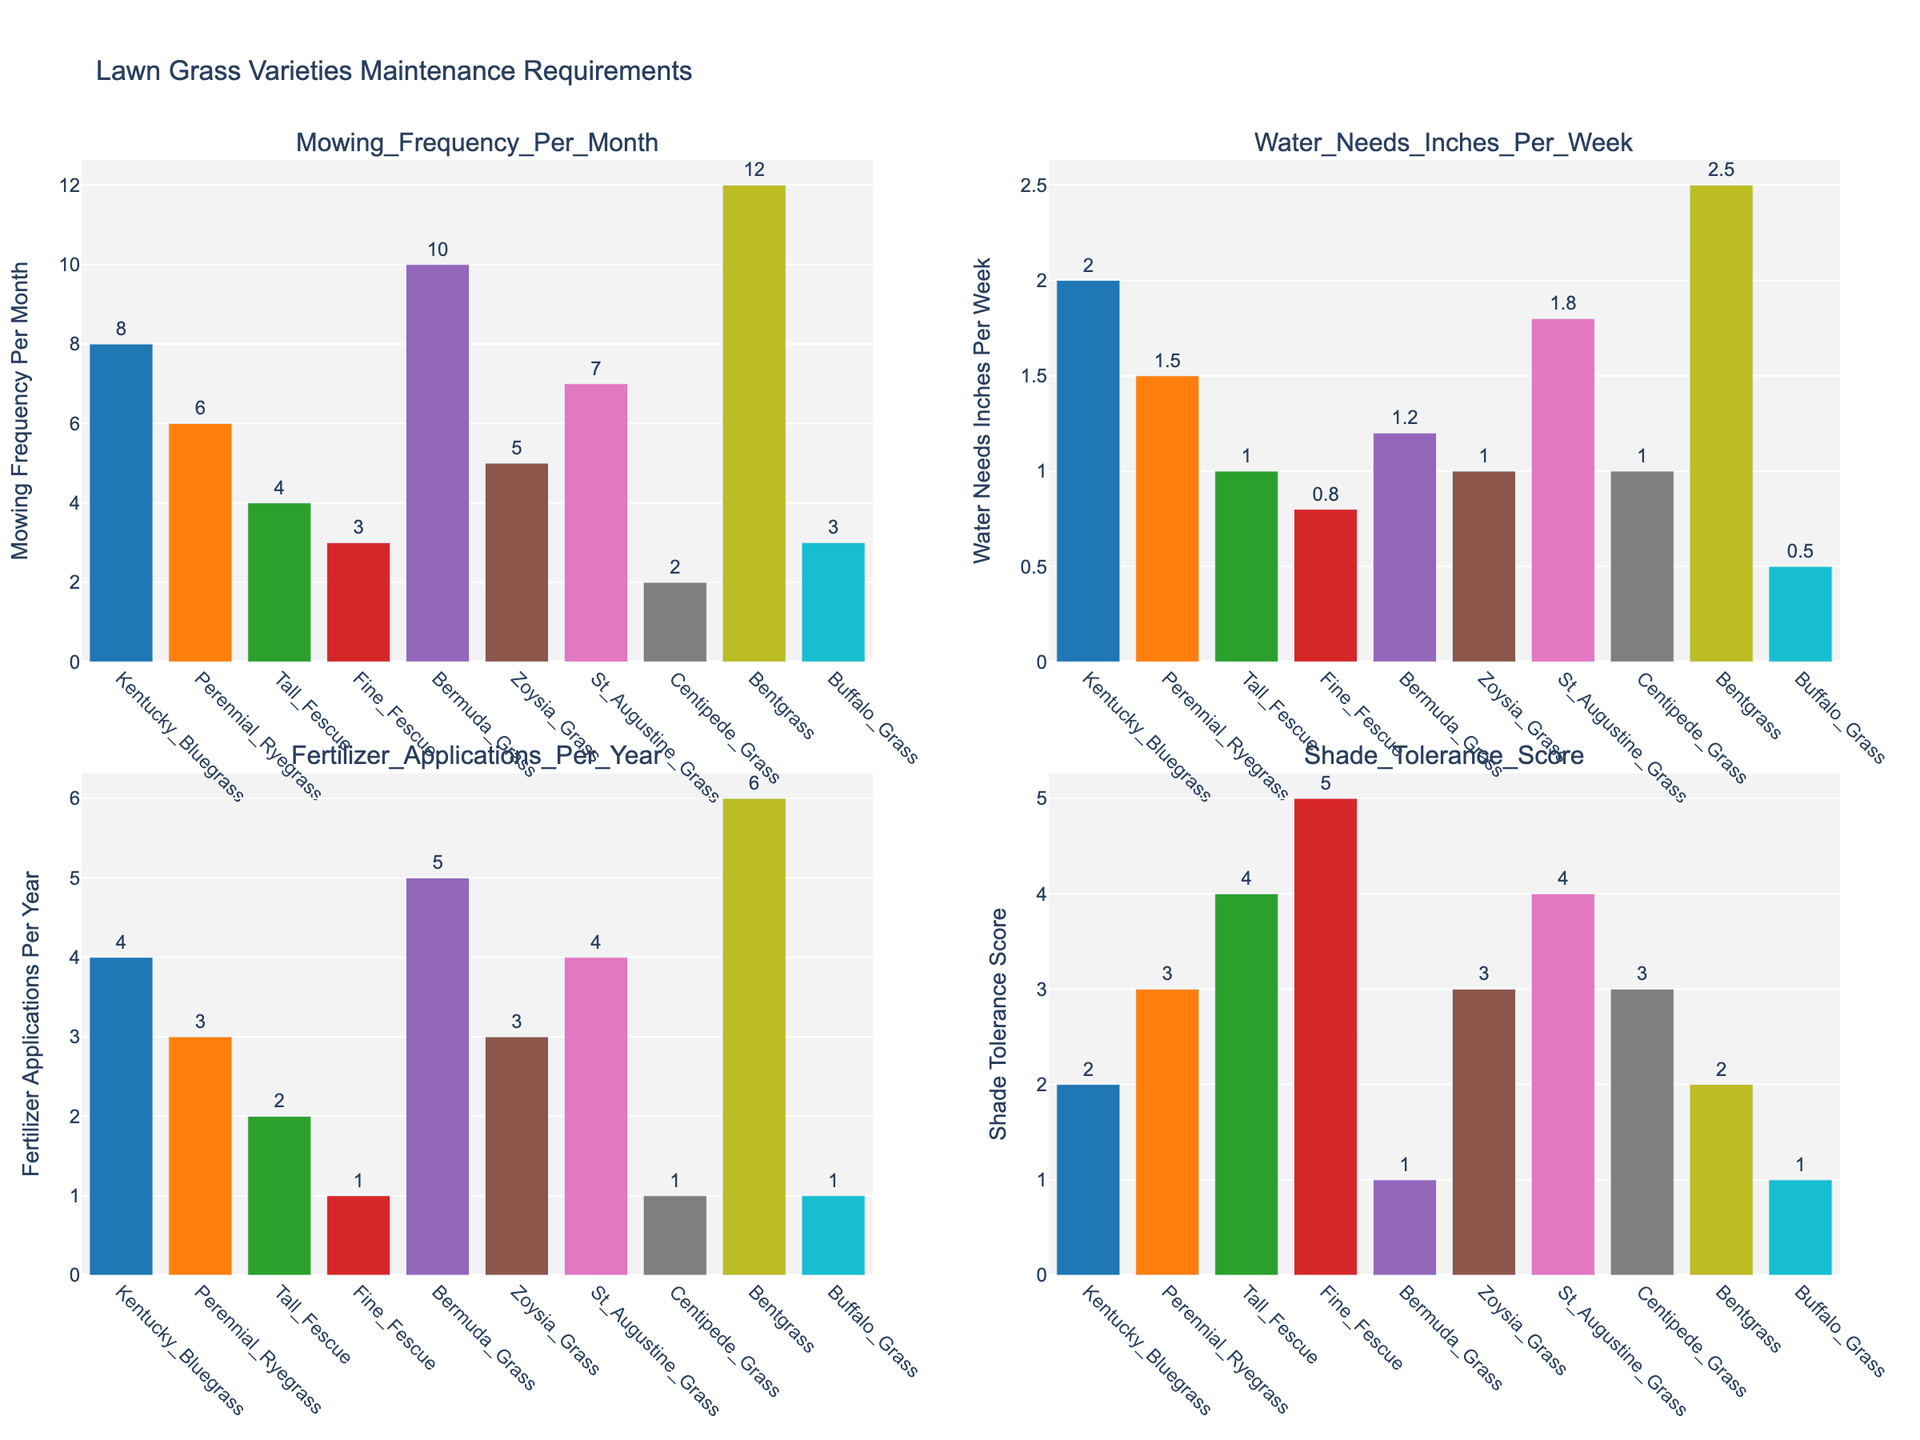Which grass variety has the highest mowing frequency per month? The tallest bar in the "Mowing Frequency Per Month" subplot represents the grass variety with the highest mowing frequency. Bentgrass has the tallest bar.
Answer: Bentgrass How many inches of water does Kentucky Bluegrass need per week? In the "Water Needs Inches Per Week" subplot, identify the bar for Kentucky Bluegrass and read the value at the top of the bar.
Answer: 2 inches Which grass variety needs the least amount of fertilizer applications per year? In the "Fertilizer Applications Per Year" subplot, find the shortest bar, which represents the grass variety with the least frequency of fertilizer applications. Centipede Grass has the shortest bar.
Answer: Centipede Grass What is the difference in water needs per week between Bentgrass and Buffalo Grass? In the "Water Needs Inches Per Week" subplot, find the values for Bentgrass (2.5 inches) and Buffalo Grass (0.5 inches), then subtract the Buffalo Grass value from the Bentgrass value.
Answer: 2 inches Which grass variety has the highest shade tolerance score? In the "Shade Tolerance Score" subplot, find the tallest bar, which represents the grass variety with the highest shade tolerance score. Fine Fescue has the tallest bar.
Answer: Fine Fescue Is Perennial Ryegrass or Tall Fescue better for shaded areas? Compare the height of the bars representing Perennial Ryegrass and Tall Fescue in the "Shade Tolerance Score" subplot. Tall Fescue has a higher bar, indicating it is better for shaded areas.
Answer: Tall Fescue What is the average mowing frequency per month for Zoysia Grass and St. Augustine Grass? In the "Mowing Frequency Per Month" subplot, find the values for Zoysia Grass (5) and St. Augustine Grass (7), add them together and divide by 2 to find the average. (5 + 7) / 2 = 6
Answer: 6 Which grass variety requires the most fertilizer applications per year? In the "Fertilizer Applications Per Year" subplot, find the tallest bar, which represents the grass variety that requires the most fertilizer applications. Bentgrass has the tallest bar.
Answer: Bentgrass Are there any grass varieties with equal water needs per week? In the "Water Needs Inches Per Week" subplot, check for bars with the same height. Zoysia Grass and Tall Fescue both have bars with the same height (1 inch).
Answer: Zoysia Grass and Tall Fescue What is the combined water needs per week for all the grass varieties? Add the values of all the bars in the "Water Needs Inches Per Week" subplot: 2 + 1.5 + 1 + 0.8 + 1.2 + 1 + 1.8 + 1 + 2.5 + 0.5 = 12.3 inches
Answer: 12.3 inches 